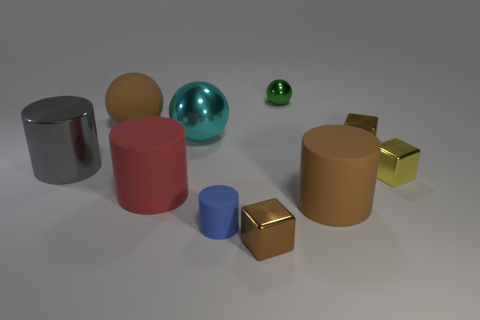There is a metallic object that is on the right side of the tiny brown block that is right of the big brown matte cylinder; is there a metal cylinder to the left of it?
Provide a short and direct response. Yes. Do the tiny ball and the cylinder that is on the left side of the large red matte thing have the same material?
Your response must be concise. Yes. What is the color of the big object that is on the right side of the small brown object that is in front of the gray cylinder?
Give a very brief answer. Brown. Is there a metallic object of the same color as the tiny ball?
Offer a terse response. No. How big is the brown matte object that is left of the small cube in front of the big red rubber object that is right of the gray shiny cylinder?
Ensure brevity in your answer.  Large. There is a tiny matte thing; is its shape the same as the small yellow thing that is in front of the large gray object?
Offer a terse response. No. How many other objects are the same size as the cyan object?
Offer a very short reply. 4. What is the size of the brown shiny thing in front of the large gray metallic cylinder?
Offer a terse response. Small. How many tiny objects have the same material as the large cyan sphere?
Ensure brevity in your answer.  4. There is a large matte thing that is right of the tiny green ball; is its shape the same as the small blue rubber object?
Offer a very short reply. Yes. 